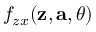Convert formula to latex. <formula><loc_0><loc_0><loc_500><loc_500>f _ { z x } ( z , a , \theta )</formula> 